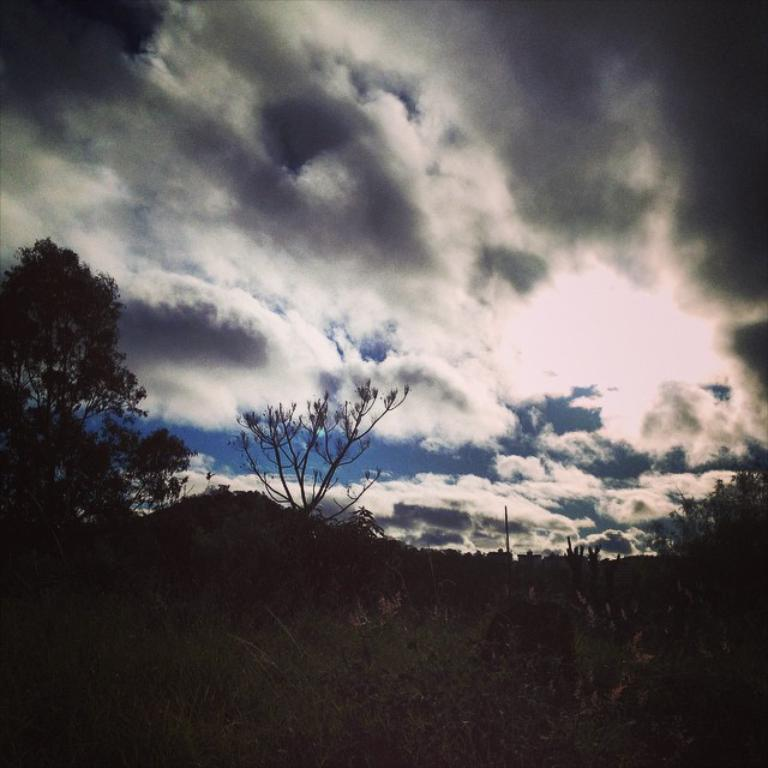What type of vegetation can be seen in the image? There are plants and a tree in the image. What is visible in the background of the image? The sky is visible in the background of the image. What can be seen in the sky? Clouds are present in the sky. How many deer can be seen in the image? There are no deer present in the image. What type of wood is the tree made of in the image? The type of wood the tree is made of cannot be determined from the image. 